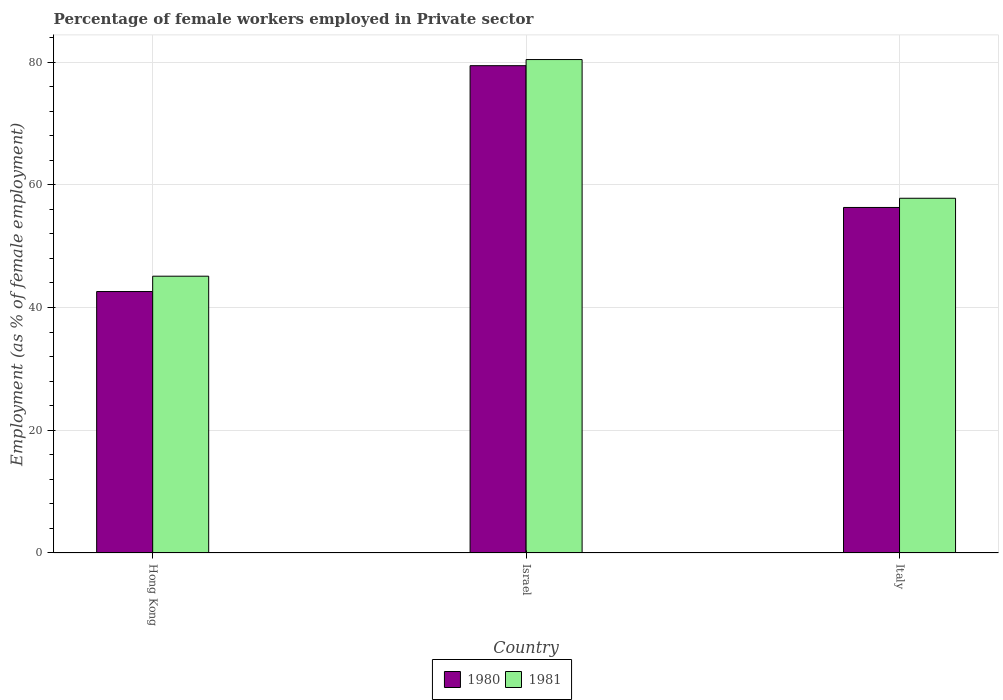How many different coloured bars are there?
Your answer should be very brief. 2. Are the number of bars per tick equal to the number of legend labels?
Make the answer very short. Yes. What is the label of the 2nd group of bars from the left?
Offer a terse response. Israel. In how many cases, is the number of bars for a given country not equal to the number of legend labels?
Offer a terse response. 0. What is the percentage of females employed in Private sector in 1981 in Hong Kong?
Give a very brief answer. 45.1. Across all countries, what is the maximum percentage of females employed in Private sector in 1980?
Give a very brief answer. 79.4. Across all countries, what is the minimum percentage of females employed in Private sector in 1980?
Your answer should be very brief. 42.6. In which country was the percentage of females employed in Private sector in 1980 maximum?
Provide a succinct answer. Israel. In which country was the percentage of females employed in Private sector in 1980 minimum?
Offer a very short reply. Hong Kong. What is the total percentage of females employed in Private sector in 1981 in the graph?
Offer a terse response. 183.3. What is the difference between the percentage of females employed in Private sector in 1980 in Hong Kong and that in Italy?
Your response must be concise. -13.7. What is the difference between the percentage of females employed in Private sector in 1980 in Hong Kong and the percentage of females employed in Private sector in 1981 in Italy?
Your response must be concise. -15.2. What is the average percentage of females employed in Private sector in 1980 per country?
Make the answer very short. 59.43. What is the difference between the percentage of females employed in Private sector of/in 1980 and percentage of females employed in Private sector of/in 1981 in Israel?
Provide a succinct answer. -1. What is the ratio of the percentage of females employed in Private sector in 1980 in Hong Kong to that in Israel?
Your response must be concise. 0.54. Is the percentage of females employed in Private sector in 1981 in Israel less than that in Italy?
Provide a short and direct response. No. Is the difference between the percentage of females employed in Private sector in 1980 in Israel and Italy greater than the difference between the percentage of females employed in Private sector in 1981 in Israel and Italy?
Your answer should be compact. Yes. What is the difference between the highest and the second highest percentage of females employed in Private sector in 1981?
Your answer should be compact. 22.6. What is the difference between the highest and the lowest percentage of females employed in Private sector in 1981?
Your answer should be very brief. 35.3. What is the difference between two consecutive major ticks on the Y-axis?
Your answer should be compact. 20. Are the values on the major ticks of Y-axis written in scientific E-notation?
Your response must be concise. No. Does the graph contain any zero values?
Your answer should be very brief. No. Does the graph contain grids?
Provide a short and direct response. Yes. Where does the legend appear in the graph?
Keep it short and to the point. Bottom center. How are the legend labels stacked?
Offer a very short reply. Horizontal. What is the title of the graph?
Keep it short and to the point. Percentage of female workers employed in Private sector. What is the label or title of the X-axis?
Provide a succinct answer. Country. What is the label or title of the Y-axis?
Offer a very short reply. Employment (as % of female employment). What is the Employment (as % of female employment) in 1980 in Hong Kong?
Ensure brevity in your answer.  42.6. What is the Employment (as % of female employment) of 1981 in Hong Kong?
Provide a short and direct response. 45.1. What is the Employment (as % of female employment) of 1980 in Israel?
Your answer should be very brief. 79.4. What is the Employment (as % of female employment) of 1981 in Israel?
Your response must be concise. 80.4. What is the Employment (as % of female employment) of 1980 in Italy?
Offer a very short reply. 56.3. What is the Employment (as % of female employment) in 1981 in Italy?
Give a very brief answer. 57.8. Across all countries, what is the maximum Employment (as % of female employment) in 1980?
Offer a terse response. 79.4. Across all countries, what is the maximum Employment (as % of female employment) of 1981?
Offer a very short reply. 80.4. Across all countries, what is the minimum Employment (as % of female employment) in 1980?
Provide a short and direct response. 42.6. Across all countries, what is the minimum Employment (as % of female employment) in 1981?
Your answer should be compact. 45.1. What is the total Employment (as % of female employment) of 1980 in the graph?
Offer a very short reply. 178.3. What is the total Employment (as % of female employment) of 1981 in the graph?
Offer a terse response. 183.3. What is the difference between the Employment (as % of female employment) of 1980 in Hong Kong and that in Israel?
Your response must be concise. -36.8. What is the difference between the Employment (as % of female employment) of 1981 in Hong Kong and that in Israel?
Provide a succinct answer. -35.3. What is the difference between the Employment (as % of female employment) of 1980 in Hong Kong and that in Italy?
Make the answer very short. -13.7. What is the difference between the Employment (as % of female employment) in 1980 in Israel and that in Italy?
Offer a terse response. 23.1. What is the difference between the Employment (as % of female employment) of 1981 in Israel and that in Italy?
Provide a succinct answer. 22.6. What is the difference between the Employment (as % of female employment) of 1980 in Hong Kong and the Employment (as % of female employment) of 1981 in Israel?
Offer a very short reply. -37.8. What is the difference between the Employment (as % of female employment) in 1980 in Hong Kong and the Employment (as % of female employment) in 1981 in Italy?
Give a very brief answer. -15.2. What is the difference between the Employment (as % of female employment) in 1980 in Israel and the Employment (as % of female employment) in 1981 in Italy?
Your answer should be compact. 21.6. What is the average Employment (as % of female employment) in 1980 per country?
Provide a short and direct response. 59.43. What is the average Employment (as % of female employment) in 1981 per country?
Offer a terse response. 61.1. What is the difference between the Employment (as % of female employment) of 1980 and Employment (as % of female employment) of 1981 in Israel?
Your response must be concise. -1. What is the ratio of the Employment (as % of female employment) in 1980 in Hong Kong to that in Israel?
Offer a terse response. 0.54. What is the ratio of the Employment (as % of female employment) in 1981 in Hong Kong to that in Israel?
Your response must be concise. 0.56. What is the ratio of the Employment (as % of female employment) in 1980 in Hong Kong to that in Italy?
Your answer should be very brief. 0.76. What is the ratio of the Employment (as % of female employment) of 1981 in Hong Kong to that in Italy?
Give a very brief answer. 0.78. What is the ratio of the Employment (as % of female employment) in 1980 in Israel to that in Italy?
Offer a very short reply. 1.41. What is the ratio of the Employment (as % of female employment) in 1981 in Israel to that in Italy?
Provide a succinct answer. 1.39. What is the difference between the highest and the second highest Employment (as % of female employment) of 1980?
Give a very brief answer. 23.1. What is the difference between the highest and the second highest Employment (as % of female employment) of 1981?
Give a very brief answer. 22.6. What is the difference between the highest and the lowest Employment (as % of female employment) in 1980?
Your answer should be very brief. 36.8. What is the difference between the highest and the lowest Employment (as % of female employment) in 1981?
Provide a short and direct response. 35.3. 